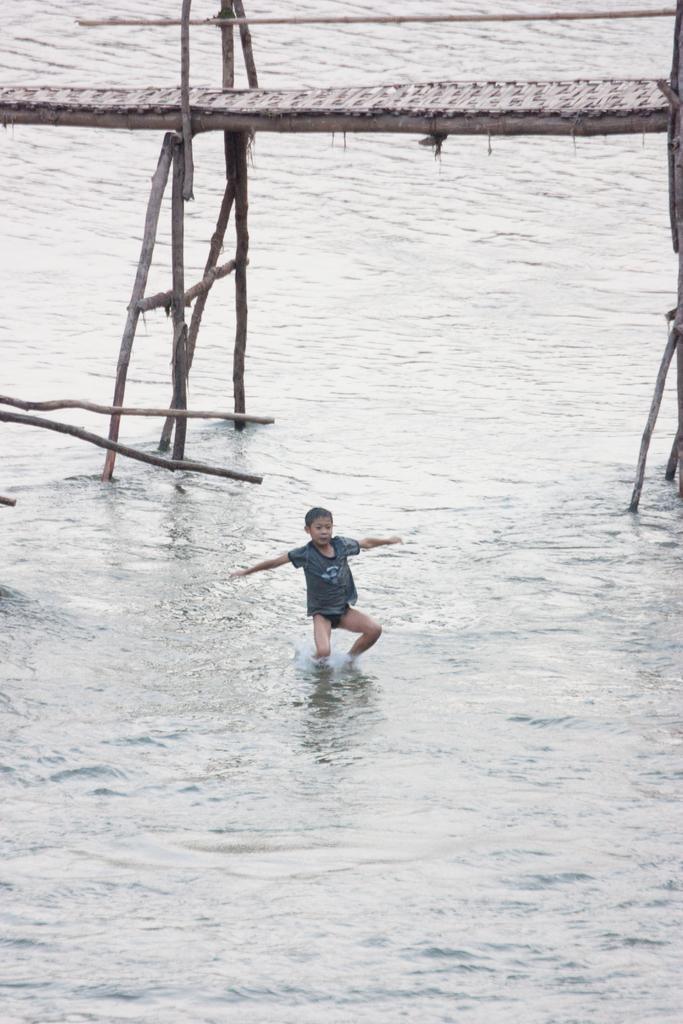How would you summarize this image in a sentence or two? In this image we can see there is a person and water. There is a bridge. 